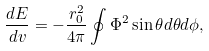<formula> <loc_0><loc_0><loc_500><loc_500>\frac { d E } { d v } = - \frac { r _ { 0 } ^ { 2 } } { 4 \pi } \oint \Phi ^ { 2 } \sin \theta d \theta d \phi ,</formula> 